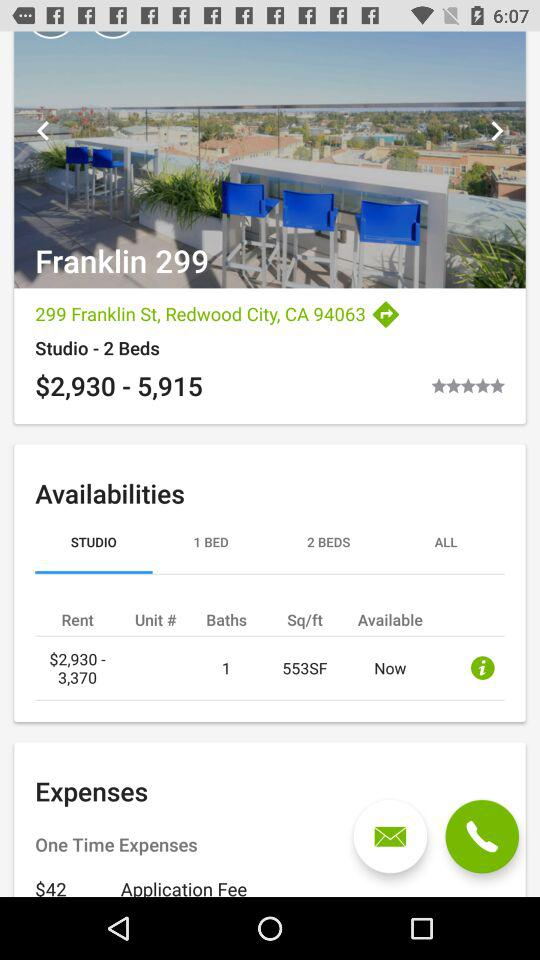What is the rating for "Franklin 299"? The rating is 5 stars. 